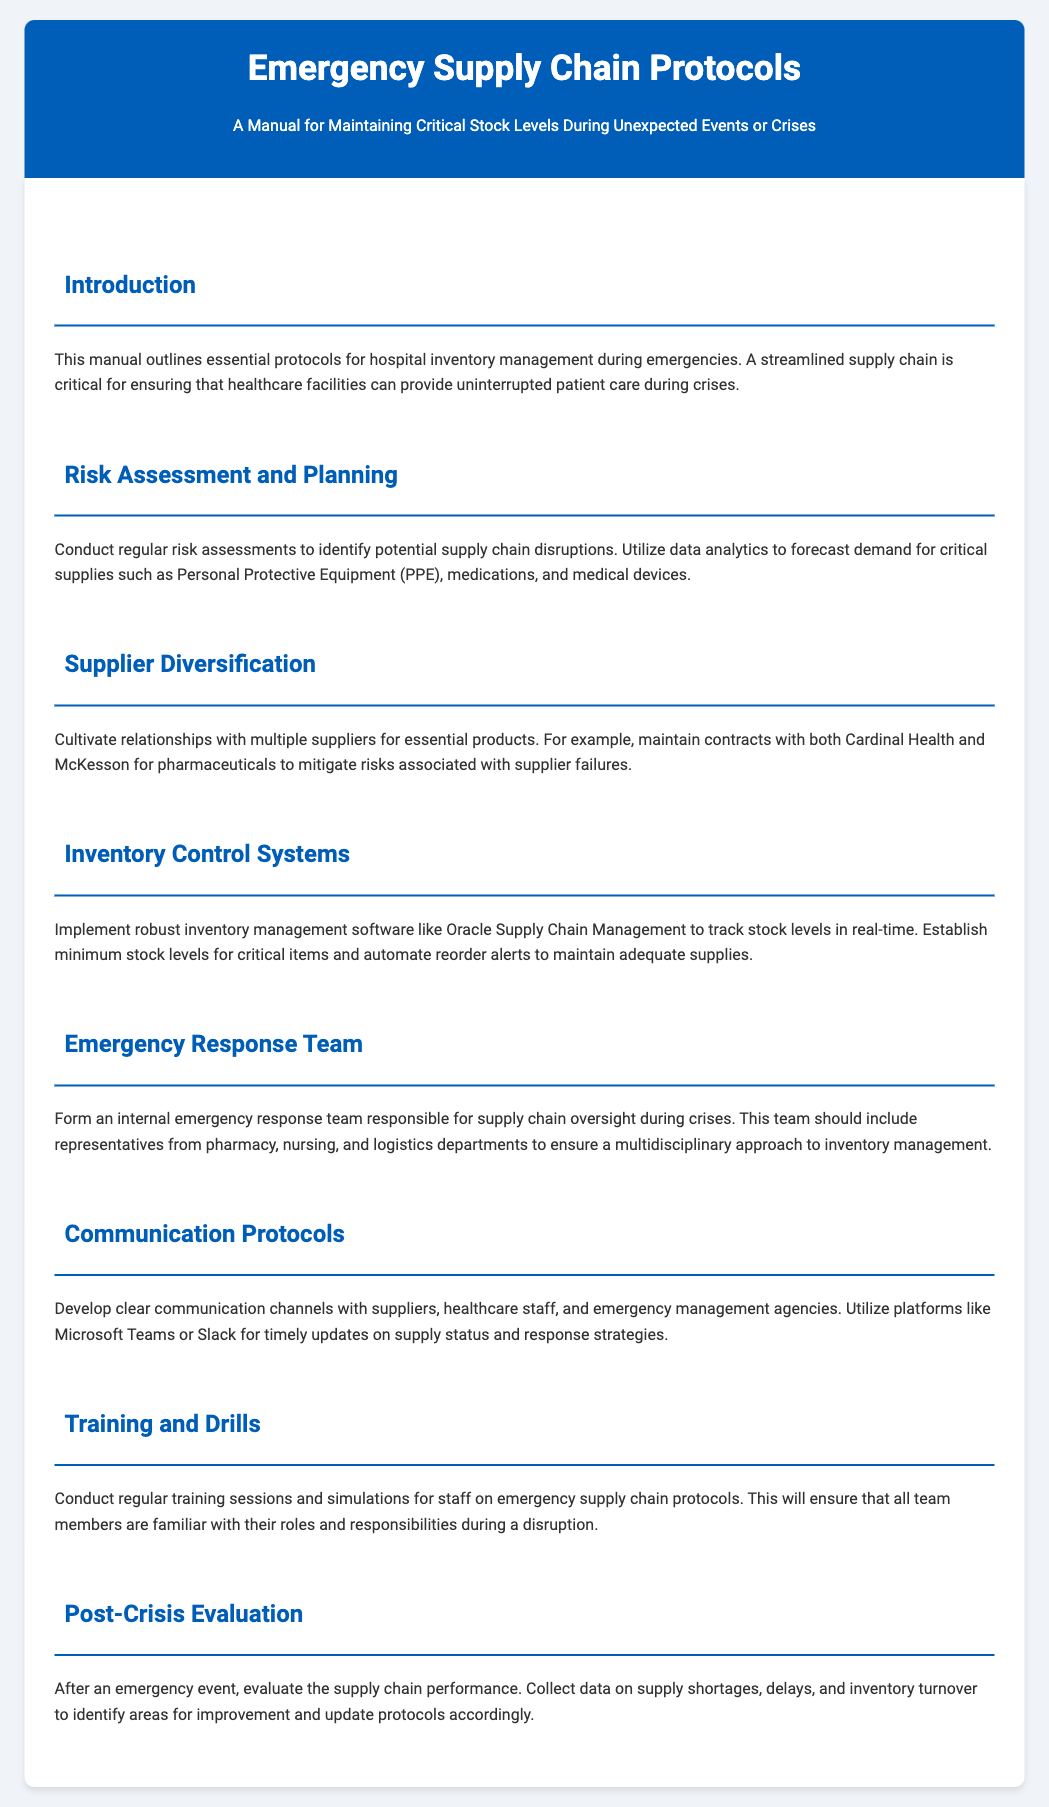what is the title of the manual? The title is prominently displayed in the header of the document.
Answer: Emergency Supply Chain Protocols what is the purpose of the manual? The purpose is described in the introduction section, highlighting the focus on hospital inventory management during emergencies.
Answer: To maintain critical stock levels during unexpected events or crises who are two recommended suppliers mentioned in the document? The document specifies suppliers in the Supplier Diversification section.
Answer: Cardinal Health and McKesson what software is suggested for inventory management? The recommended software is mentioned in the Inventory Control Systems section.
Answer: Oracle Supply Chain Management how many sections are in the content of the manual? The number of sections can be counted in the content area of the document.
Answer: Seven what should be collected for post-crisis evaluation? The document stresses the importance of certain data types in the Post-Crisis Evaluation section.
Answer: Data on supply shortages, delays, and inventory turnover who should be included in the internal emergency response team? The document indicates the roles that should be represented in this team in the Emergency Response Team section.
Answer: Representatives from pharmacy, nursing, and logistics departments 